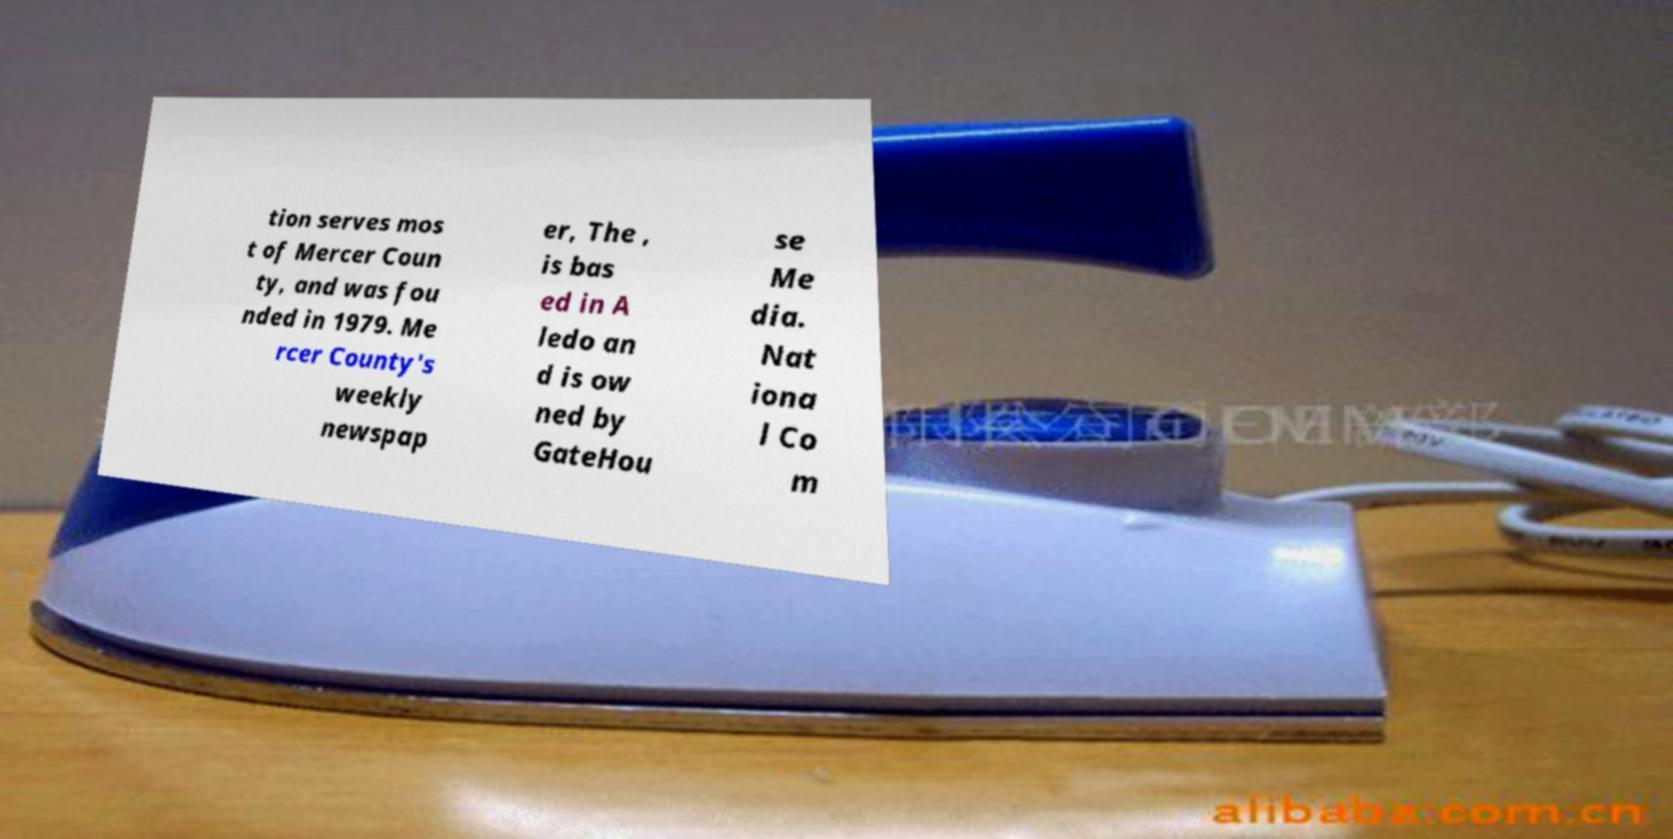Can you read and provide the text displayed in the image?This photo seems to have some interesting text. Can you extract and type it out for me? tion serves mos t of Mercer Coun ty, and was fou nded in 1979. Me rcer County's weekly newspap er, The , is bas ed in A ledo an d is ow ned by GateHou se Me dia. Nat iona l Co m 